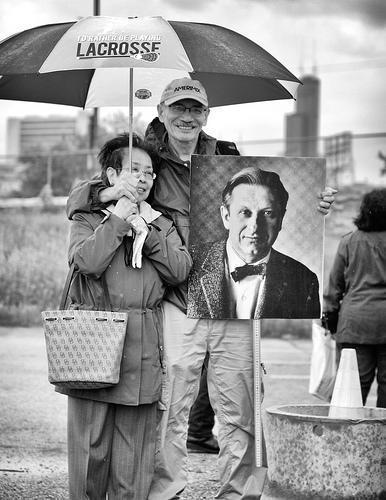How many live people are there?
Give a very brief answer. 3. 